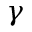Convert formula to latex. <formula><loc_0><loc_0><loc_500><loc_500>\gamma</formula> 